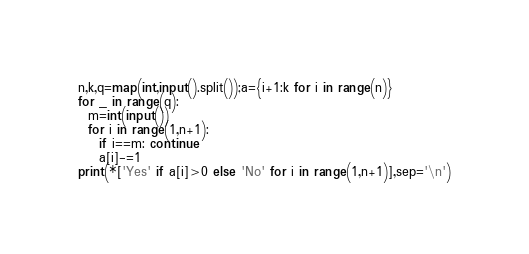Convert code to text. <code><loc_0><loc_0><loc_500><loc_500><_Python_>n,k,q=map(int,input().split());a={i+1:k for i in range(n)}
for _ in range(q):
  m=int(input())
  for i in range(1,n+1):
    if i==m: continue
    a[i]-=1
print(*['Yes' if a[i]>0 else 'No' for i in range(1,n+1)],sep='\n')</code> 